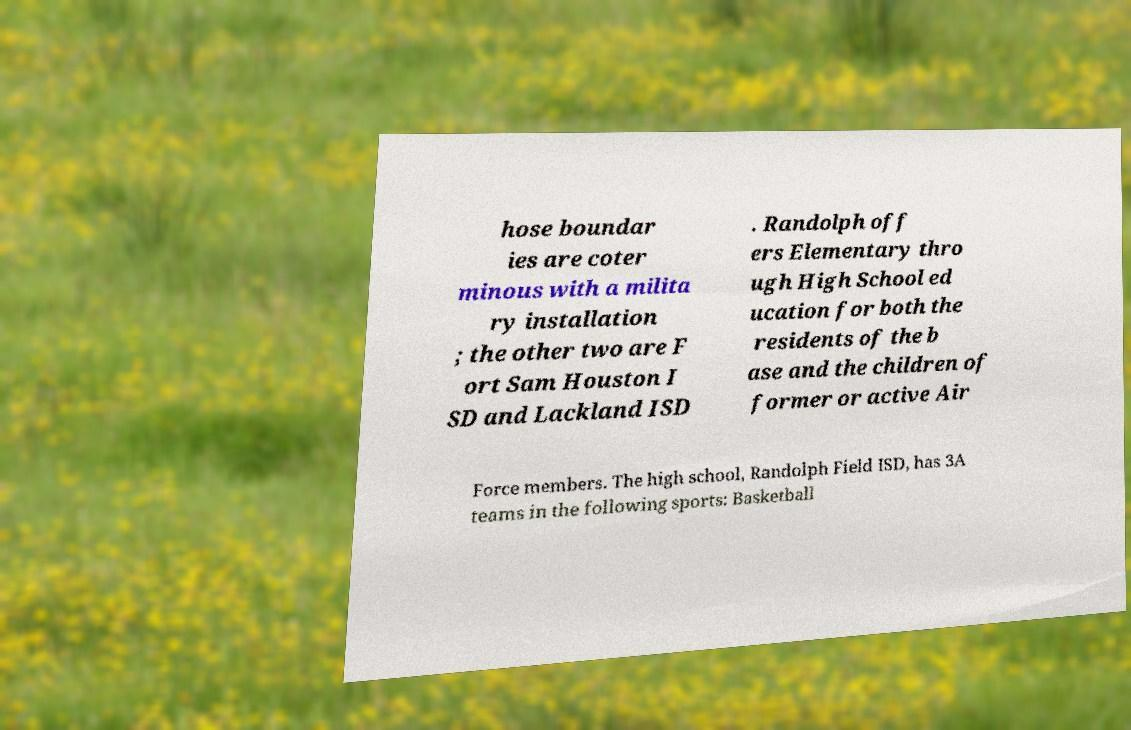For documentation purposes, I need the text within this image transcribed. Could you provide that? hose boundar ies are coter minous with a milita ry installation ; the other two are F ort Sam Houston I SD and Lackland ISD . Randolph off ers Elementary thro ugh High School ed ucation for both the residents of the b ase and the children of former or active Air Force members. The high school, Randolph Field ISD, has 3A teams in the following sports: Basketball 